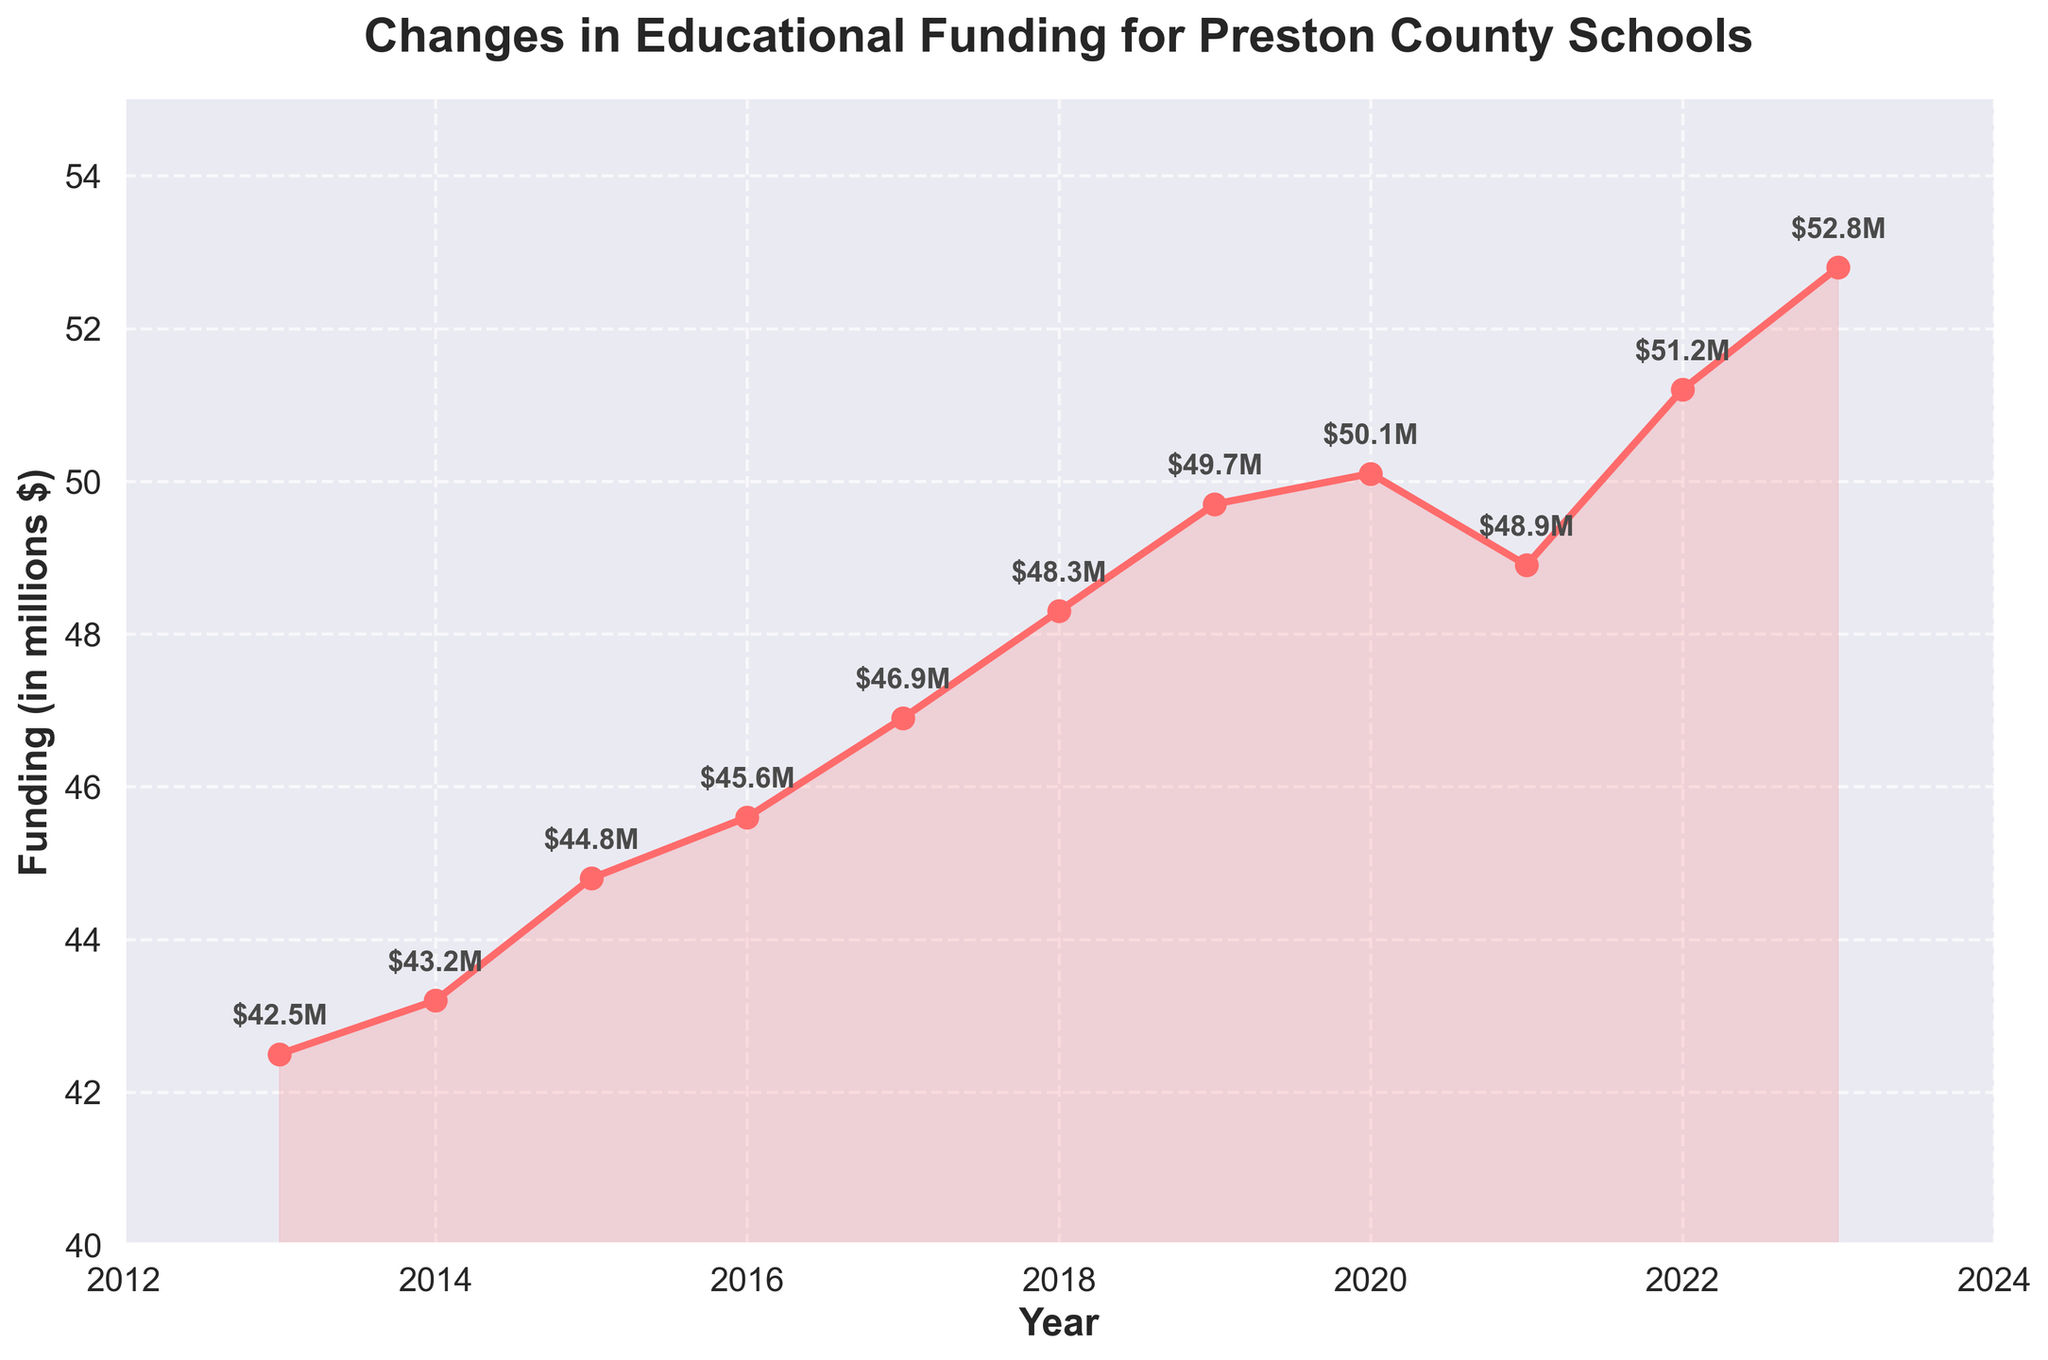what is the funding amount for Preston County schools in 2023? Locate the point corresponding to the year 2023 on the x-axis and read the funding value next to it. The value is labeled as $52.8M.
Answer: $52.8M How does the funding in 2018 compare to that in 2016? Locate the value for 2016, which is $45.6M, and for 2018, which is $48.3M. Then compare the two values. Funding in 2018 is greater than in 2016.
Answer: Greater What is the average annual funding for the years 2017 to 2023? Sum the funding values from 2017 to 2023: (46.9 + 48.3 + 49.7 + 50.1 + 48.9 + 51.2 + 52.8) = 348.9, then divide by the number of years, which is 7. The average funding is 348.9/7 = 49.84.
Answer: 49.84 What year saw the largest single-year increase in funding? Calculate the differences for consecutive years: 2013-2014 (0.7), 2014-2015 (1.6), 2015-2016 (0.8), 2016-2017 (1.3), 2017-2018 (1.4), 2018-2019 (1.4), 2019-2020 (0.4), 2020-2021 (-1.2), 2021-2022 (2.3), 2022-2023 (1.6). The largest increase was from 2021 to 2022, an increase of 2.3.
Answer: 2021-2022 In which years was the funding amount below $45 million? Locate the funding values above which are below $45 million: 2013 ($42.5M), 2014 ($43.2M). The years are 2013 and 2014.
Answer: 2013, 2014 What's the percentage increase in funding from 2013 to 2023? Use the formula [(52.8 - 42.5)/42.5] * 100. The percentage increase is [(52.8 - 42.5)/42.5] * 100 = 24.24%.
Answer: 24.24% What trend can you observe for the funding from 2013 to 2023? Observe the line, it generally shows an upward trend with a slight dip from 2020 to 2021. Overall, funding increased over the decade.
Answer: Increasing trend When did the funding experience a decline, and by how much? A decline occurred from 2020 to 2021: (50.1 - 48.9) = 1.2M.
Answer: 2020-2021, $1.2M Which year had a funding amount of $50.1 million? Locate the funding value ($50.1M) and see which year it corresponds to; it matches with 2020.
Answer: 2020 